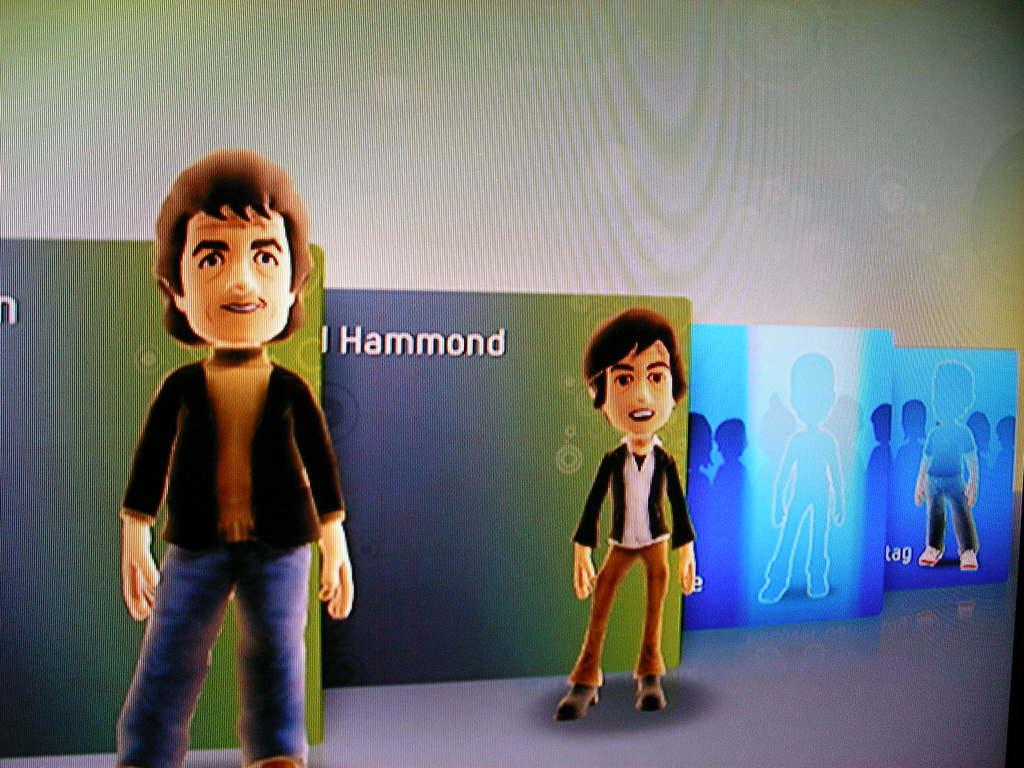What type of picture is in the image? The image contains an animated picture. How many people are in the image? There are two persons standing in the image. What can be seen around the animated picture? There are frames visible in the image. What color is the background of the image? The background of the image is white. What type of underwear is the person on the left wearing in the image? There is no information about the person's underwear in the image, as it is an animated picture and not a photograph. 